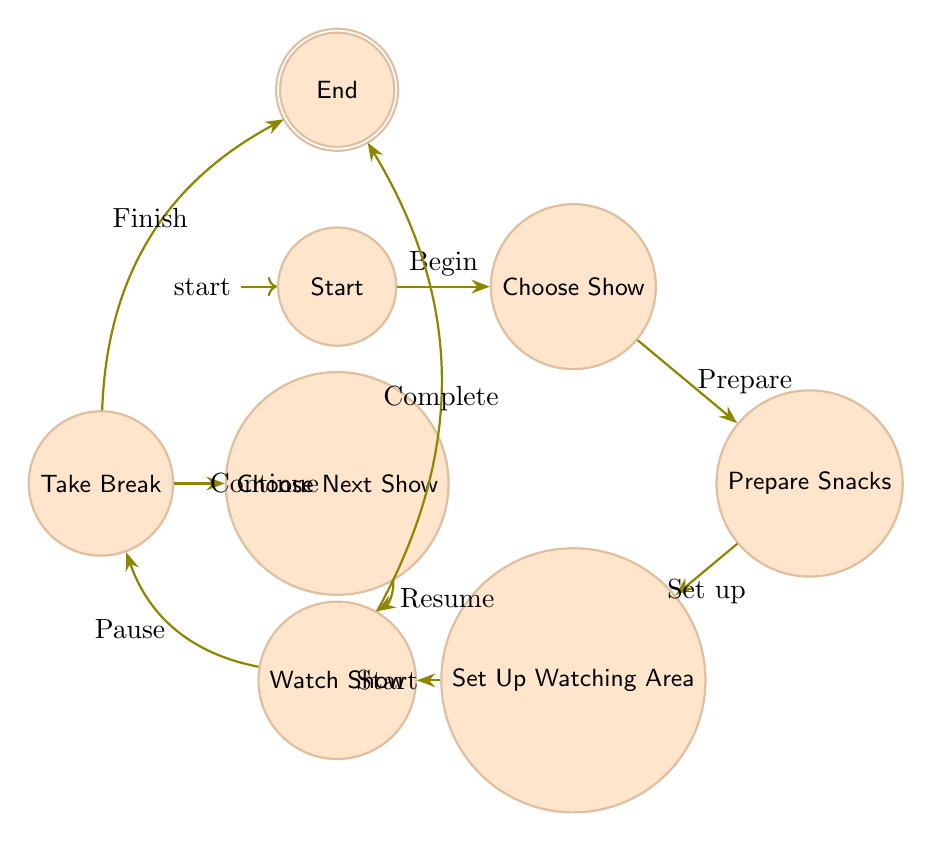What is the initial state of the diagram? The initial state is represented as "Start," which is where planning begins for the retro TV marathon.
Answer: Start How many total states are in the diagram? There are eight states listed in the diagram: Start, Choose Show, Prepare Snacks, Set Up Watching Area, Watch Show, Take Break, Choose Next Show, and End.
Answer: 8 Which state comes after "Prepare Snacks"? The state directly following "Prepare Snacks" is "Set Up Watching Area," indicating that after gathering snacks, the next step is to arrange the viewing area.
Answer: Set Up Watching Area What is the final state of the diagram? The final state is "End," which signifies the conclusion of the marathon and the cleaning up process.
Answer: End What action leads from "Watch Show" to "End"? The action that leads from "Watch Show" to "End" is "Decide to finish the marathon and clean up," indicating the completion of watching shows.
Answer: Decide to finish Which state requires you to "Take a break"? The state requiring a break is "Take Break," which follows the action of watching a show and occurs after completing an episode or show.
Answer: Take Break What is the transition from "Take Break" if the marathon is not over? If the marathon is not over, the transition from "Take Break" leads to "Choose Next Show," indicating the decision to select another show to watch.
Answer: Choose Next Show What is the relationship between "Choose Show" and "Prepare Snacks"? The relationship is that once a show is chosen, it leads directly to the next state, "Prepare Snacks," which indicates the need to gather snacks.
Answer: Prepare Snacks Which state requires setting up the viewing area? The state that requires setting up the viewing area is "Set Up Watching Area," which follows the preparation of snacks.
Answer: Set Up Watching Area 